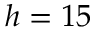Convert formula to latex. <formula><loc_0><loc_0><loc_500><loc_500>h = 1 5</formula> 